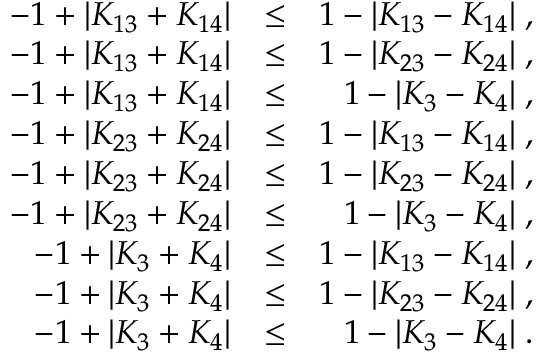Convert formula to latex. <formula><loc_0><loc_0><loc_500><loc_500>\begin{array} { r l r } { - 1 + | K _ { 1 3 } + K _ { 1 4 } | } & { \leq } & { 1 - | K _ { 1 3 } - K _ { 1 4 } | \, , } \\ { - 1 + | K _ { 1 3 } + K _ { 1 4 } | } & { \leq } & { 1 - | K _ { 2 3 } - K _ { 2 4 } | \, , } \\ { - 1 + | K _ { 1 3 } + K _ { 1 4 } | } & { \leq } & { 1 - | K _ { 3 } - K _ { 4 } | \, , } \\ { - 1 + | K _ { 2 3 } + K _ { 2 4 } | } & { \leq } & { 1 - | K _ { 1 3 } - K _ { 1 4 } | \, , } \\ { - 1 + | K _ { 2 3 } + K _ { 2 4 } | } & { \leq } & { 1 - | K _ { 2 3 } - K _ { 2 4 } | \, , } \\ { - 1 + | K _ { 2 3 } + K _ { 2 4 } | } & { \leq } & { 1 - | K _ { 3 } - K _ { 4 } | \, , } \\ { - 1 + | K _ { 3 } + K _ { 4 } | } & { \leq } & { 1 - | K _ { 1 3 } - K _ { 1 4 } | \, , } \\ { - 1 + | K _ { 3 } + K _ { 4 } | } & { \leq } & { 1 - | K _ { 2 3 } - K _ { 2 4 } | \, , } \\ { - 1 + | K _ { 3 } + K _ { 4 } | } & { \leq } & { 1 - | K _ { 3 } - K _ { 4 } | \, . } \end{array}</formula> 